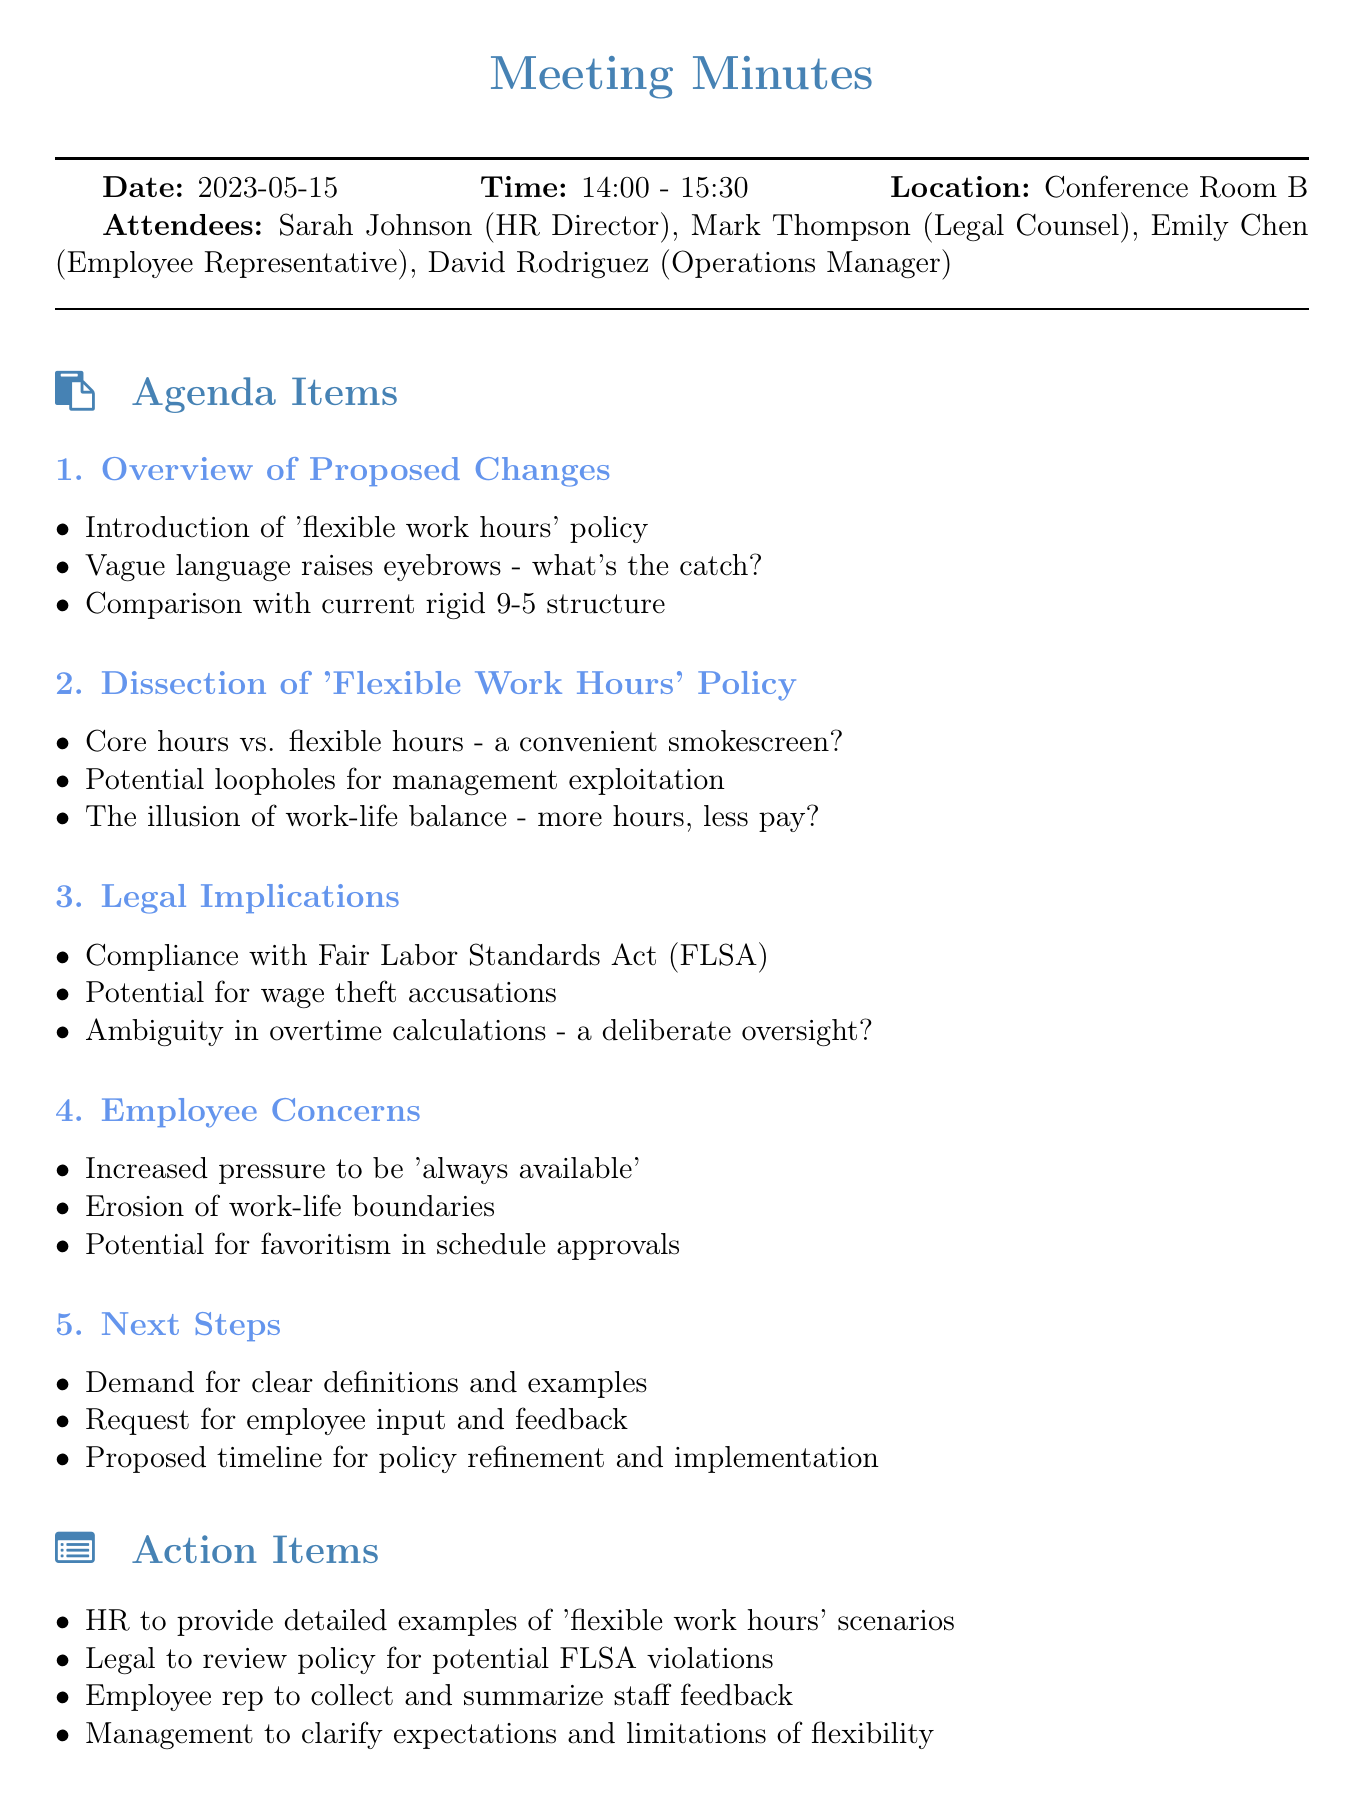What date was the meeting held? The meeting was held on the date listed in the document, which is stated explicitly.
Answer: 2023-05-15 Who is the HR Director? The document specifies the attendees, including their roles, which helps identify the HR Director.
Answer: Sarah Johnson What is the main new policy introduced? The agenda item clearly states the policy being discussed in the meeting.
Answer: flexible work hours What are the potential issues raised about the flexible work hours policy? The document outlines specific points questioning the policy, indicating concerns about its implementation.
Answer: management exploitation What is the first action item? The action items section lists tasks that need to be completed following the meeting, revealing the first action.
Answer: HR to provide detailed examples of 'flexible work hours' scenarios What concern involves employee availability? Several points under employee concerns highlight specific issues, one of which refers to availability expectations.
Answer: always available How long did the meeting last? The document includes the start and end time of the meeting, allowing for a calculation of its duration.
Answer: 1.5 hours What legal consideration is mentioned regarding the new policy? The legal implications section points out specific laws that the policy must comply with, which raises concerns.
Answer: Fair Labor Standards Act (FLSA) What does the meeting suggest is necessary for the policy refinement? The next steps section discusses the need for employee feedback, indicating what is required for further development.
Answer: clear definitions and examples 